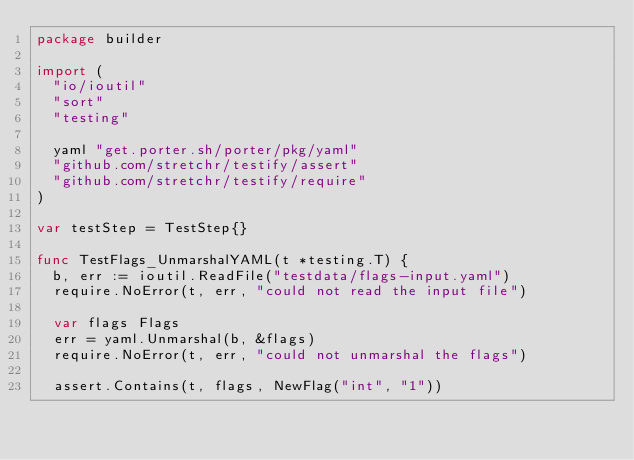Convert code to text. <code><loc_0><loc_0><loc_500><loc_500><_Go_>package builder

import (
	"io/ioutil"
	"sort"
	"testing"

	yaml "get.porter.sh/porter/pkg/yaml"
	"github.com/stretchr/testify/assert"
	"github.com/stretchr/testify/require"
)

var testStep = TestStep{}

func TestFlags_UnmarshalYAML(t *testing.T) {
	b, err := ioutil.ReadFile("testdata/flags-input.yaml")
	require.NoError(t, err, "could not read the input file")

	var flags Flags
	err = yaml.Unmarshal(b, &flags)
	require.NoError(t, err, "could not unmarshal the flags")

	assert.Contains(t, flags, NewFlag("int", "1"))</code> 